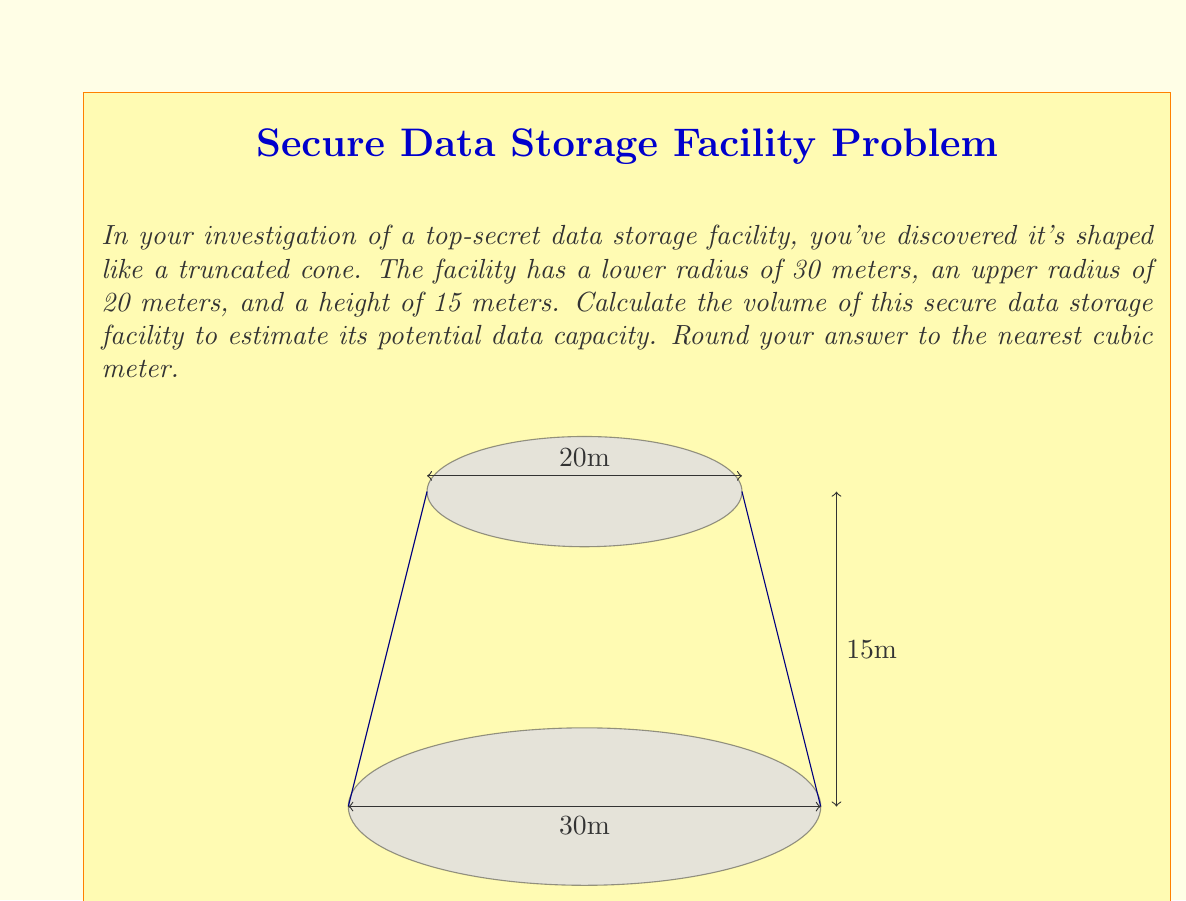Provide a solution to this math problem. To calculate the volume of a truncated cone, we use the formula:

$$V = \frac{1}{3}\pi h(R^2 + r^2 + Rr)$$

Where:
$V$ = Volume
$h$ = Height
$R$ = Radius of the lower base
$r$ = Radius of the upper base

Let's substitute our known values:

$h = 15$ meters
$R = 30$ meters
$r = 20$ meters

Now, let's calculate step by step:

1) First, let's calculate $R^2$, $r^2$, and $Rr$:
   $R^2 = 30^2 = 900$
   $r^2 = 20^2 = 400$
   $Rr = 30 \times 20 = 600$

2) Now, let's add these values:
   $R^2 + r^2 + Rr = 900 + 400 + 600 = 1900$

3) Multiply this by $h$:
   $h(R^2 + r^2 + Rr) = 15 \times 1900 = 28500$

4) Multiply by $\frac{1}{3}\pi$:
   $V = \frac{1}{3}\pi \times 28500 \approx 29845.13$

5) Rounding to the nearest cubic meter:
   $V \approx 29845$ cubic meters
Answer: The volume of the secure data storage facility is approximately 29,845 cubic meters. 